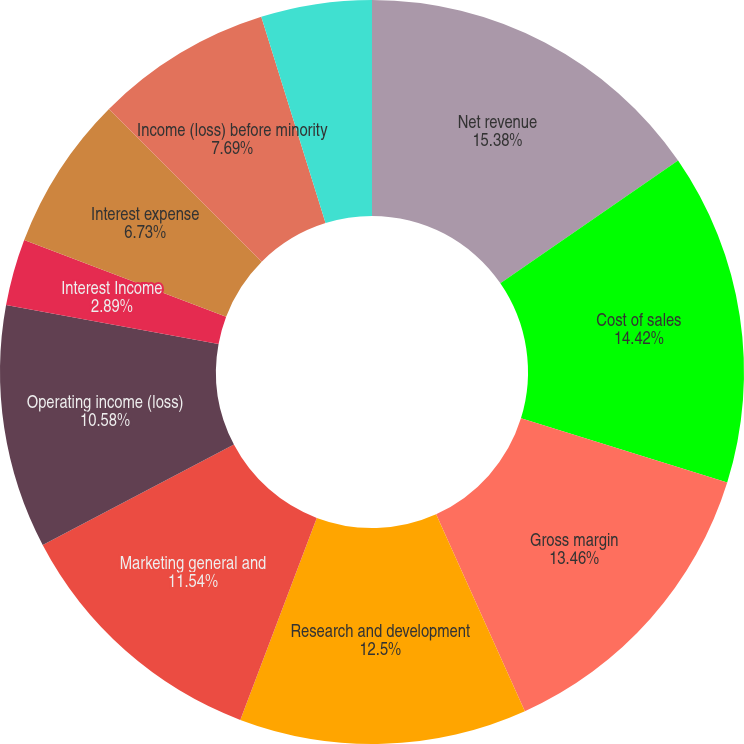Convert chart. <chart><loc_0><loc_0><loc_500><loc_500><pie_chart><fcel>Net revenue<fcel>Cost of sales<fcel>Gross margin<fcel>Research and development<fcel>Marketing general and<fcel>Operating income (loss)<fcel>Interest Income<fcel>Interest expense<fcel>Income (loss) before minority<fcel>Minority interest in<nl><fcel>15.38%<fcel>14.42%<fcel>13.46%<fcel>12.5%<fcel>11.54%<fcel>10.58%<fcel>2.89%<fcel>6.73%<fcel>7.69%<fcel>4.81%<nl></chart> 